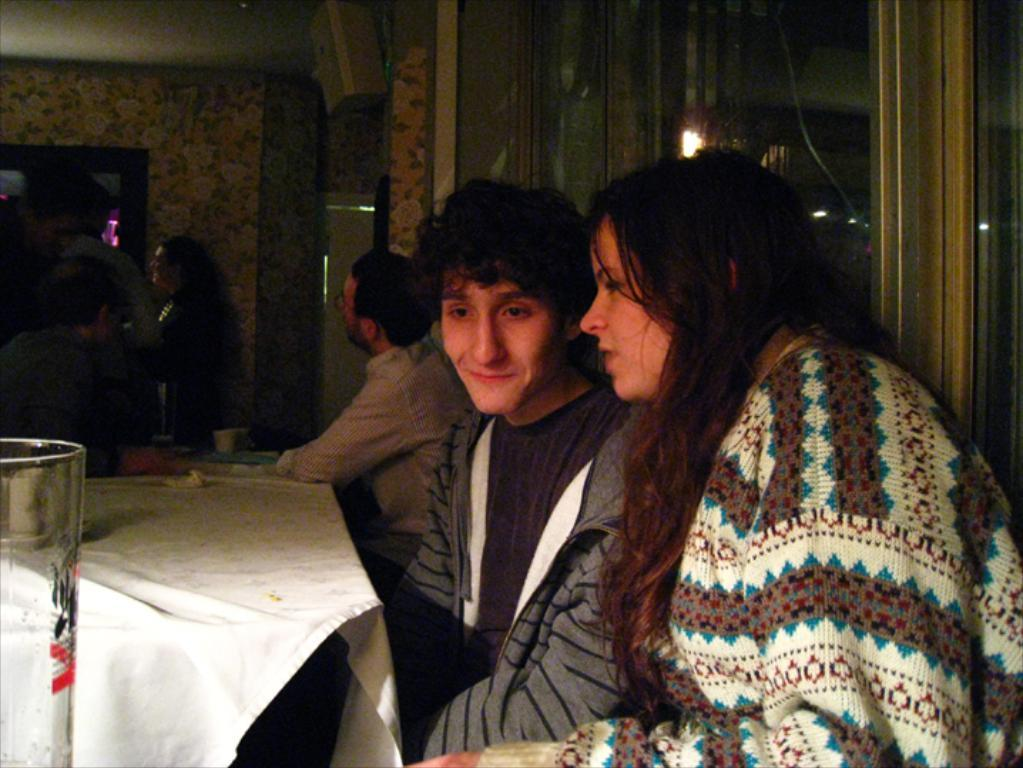How many people are sitting in the chairs in the image? There are two persons sitting on chairs in the image. What is on the table in the image? There is a glass on a table in the image. What are the people near the sitting persons doing? There is a group of people standing nearby. What can be seen in the background of the image? There is a wall visible in the image. What type of bear can be seen interacting with the group of people in the image? There is no bear present in the image; it features two persons sitting on chairs, a glass on a table, a group of people standing nearby, and a wall in the background. What is the account number of the person sitting on the left chair in the image? There is no account number visible in the image, as it only shows two persons sitting on chairs, a glass on a table, a group of people standing nearby, and a wall in the background. 